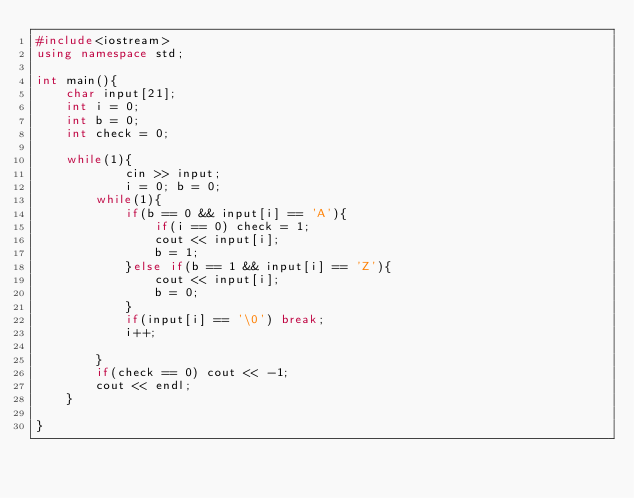Convert code to text. <code><loc_0><loc_0><loc_500><loc_500><_C++_>#include<iostream>
using namespace std;

int main(){
	char input[21];
	int i = 0;
	int b = 0;
	int check = 0;

	while(1){
			cin >> input;
			i = 0; b = 0;
		while(1){
			if(b == 0 && input[i] == 'A'){
				if(i == 0) check = 1;
				cout << input[i];
				b = 1;
			}else if(b == 1 && input[i] == 'Z'){
				cout << input[i];
				b = 0;
			}
			if(input[i] == '\0') break;
			i++;
			
		}
		if(check == 0) cout << -1;
		cout << endl;
	}

}</code> 